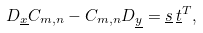Convert formula to latex. <formula><loc_0><loc_0><loc_500><loc_500>D _ { \underline { x } } C _ { m , n } - C _ { m , n } D _ { \underline { y } } = \underline { s } \, \underline { t } ^ { T } ,</formula> 